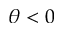<formula> <loc_0><loc_0><loc_500><loc_500>\theta < 0</formula> 